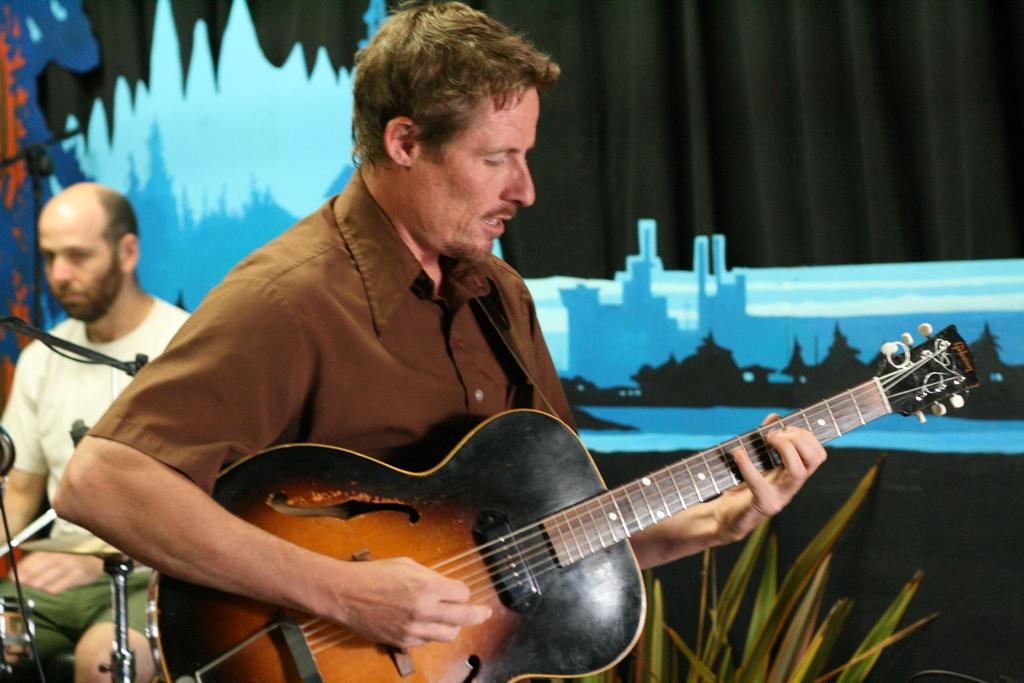How many people are in the image? There are two men in the image. What is one of the men doing in the image? One man is playing a guitar. What is the other man's position in the image? The other man is sitting on a chair. What type of fowl can be seen in the image? There is no fowl present in the image; it features two men, one playing a guitar and the other sitting on a chair. What type of fruit is the man holding in the image? There is no fruit present in the image, and neither man is holding anything. 